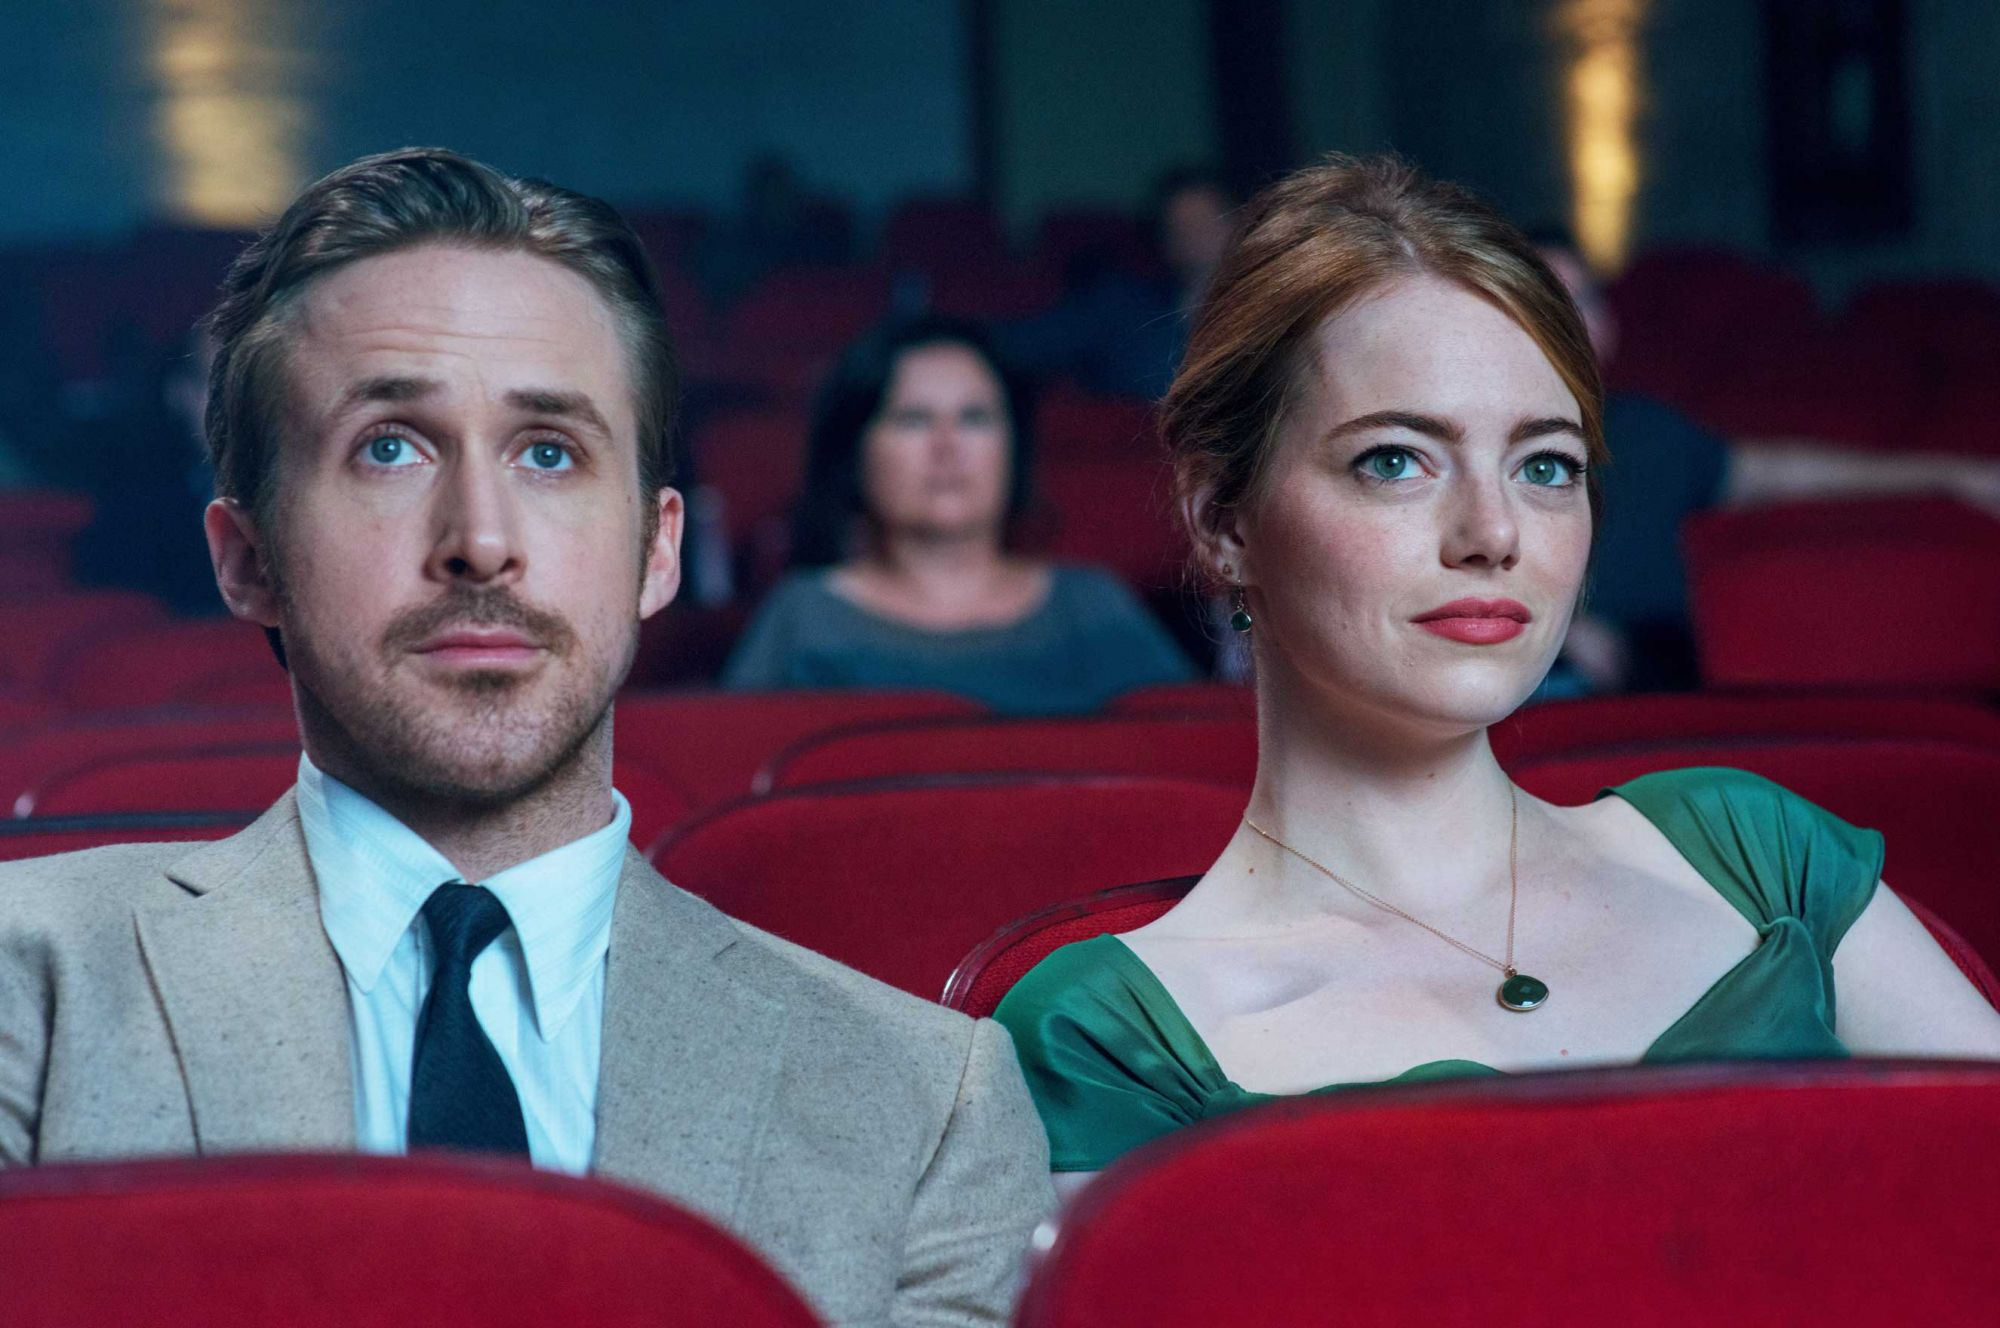What emotions can you infer from the expressions of the characters in the image? The expressions of the characters, Sebastian and Mia, convey a sense of depth and seriousness as they engage with the movie screen. Ryan’s character seems contemplative, perhaps reflecting on a pivotal moment in the film. Emma’s character appears more composed but equally engrossed, suggesting a blend of admiration and introspection. Their body language and focused gazes suggest that the scene they are watching is emotionally significant. 